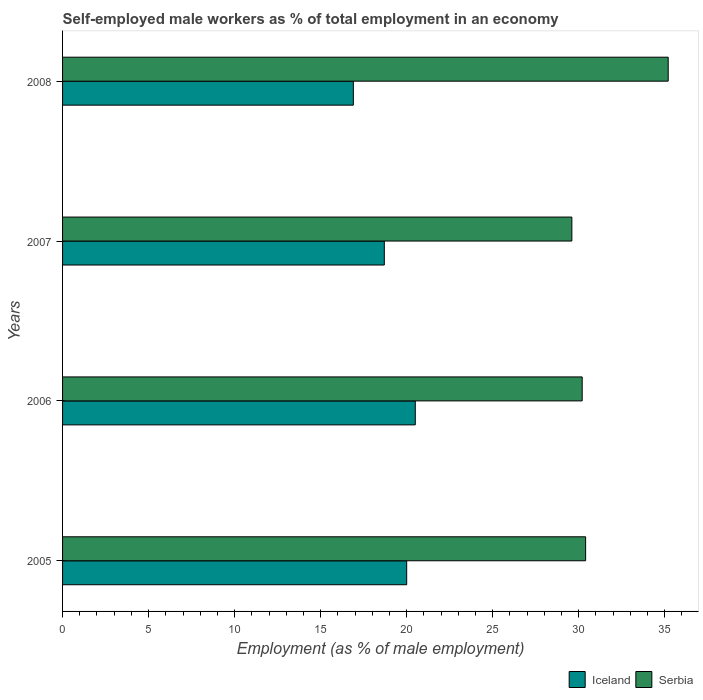How many groups of bars are there?
Keep it short and to the point. 4. Are the number of bars on each tick of the Y-axis equal?
Keep it short and to the point. Yes. How many bars are there on the 2nd tick from the bottom?
Your answer should be very brief. 2. What is the label of the 2nd group of bars from the top?
Your answer should be compact. 2007. In how many cases, is the number of bars for a given year not equal to the number of legend labels?
Your response must be concise. 0. What is the percentage of self-employed male workers in Serbia in 2006?
Your answer should be very brief. 30.2. Across all years, what is the maximum percentage of self-employed male workers in Iceland?
Offer a very short reply. 20.5. Across all years, what is the minimum percentage of self-employed male workers in Iceland?
Keep it short and to the point. 16.9. In which year was the percentage of self-employed male workers in Serbia maximum?
Give a very brief answer. 2008. What is the total percentage of self-employed male workers in Iceland in the graph?
Provide a succinct answer. 76.1. What is the difference between the percentage of self-employed male workers in Iceland in 2005 and that in 2008?
Give a very brief answer. 3.1. What is the difference between the percentage of self-employed male workers in Iceland in 2006 and the percentage of self-employed male workers in Serbia in 2007?
Ensure brevity in your answer.  -9.1. What is the average percentage of self-employed male workers in Iceland per year?
Provide a succinct answer. 19.03. In the year 2005, what is the difference between the percentage of self-employed male workers in Serbia and percentage of self-employed male workers in Iceland?
Your answer should be compact. 10.4. What is the ratio of the percentage of self-employed male workers in Iceland in 2005 to that in 2008?
Provide a short and direct response. 1.18. Is the difference between the percentage of self-employed male workers in Serbia in 2005 and 2008 greater than the difference between the percentage of self-employed male workers in Iceland in 2005 and 2008?
Offer a terse response. No. What is the difference between the highest and the second highest percentage of self-employed male workers in Serbia?
Keep it short and to the point. 4.8. What is the difference between the highest and the lowest percentage of self-employed male workers in Iceland?
Offer a very short reply. 3.6. In how many years, is the percentage of self-employed male workers in Iceland greater than the average percentage of self-employed male workers in Iceland taken over all years?
Give a very brief answer. 2. What does the 2nd bar from the bottom in 2006 represents?
Offer a terse response. Serbia. How many bars are there?
Ensure brevity in your answer.  8. How many years are there in the graph?
Give a very brief answer. 4. What is the difference between two consecutive major ticks on the X-axis?
Provide a short and direct response. 5. Are the values on the major ticks of X-axis written in scientific E-notation?
Provide a short and direct response. No. Does the graph contain grids?
Your response must be concise. No. Where does the legend appear in the graph?
Your response must be concise. Bottom right. How many legend labels are there?
Give a very brief answer. 2. What is the title of the graph?
Your answer should be very brief. Self-employed male workers as % of total employment in an economy. What is the label or title of the X-axis?
Make the answer very short. Employment (as % of male employment). What is the Employment (as % of male employment) of Serbia in 2005?
Your answer should be very brief. 30.4. What is the Employment (as % of male employment) in Iceland in 2006?
Your response must be concise. 20.5. What is the Employment (as % of male employment) of Serbia in 2006?
Keep it short and to the point. 30.2. What is the Employment (as % of male employment) of Iceland in 2007?
Ensure brevity in your answer.  18.7. What is the Employment (as % of male employment) of Serbia in 2007?
Make the answer very short. 29.6. What is the Employment (as % of male employment) in Iceland in 2008?
Offer a very short reply. 16.9. What is the Employment (as % of male employment) of Serbia in 2008?
Offer a terse response. 35.2. Across all years, what is the maximum Employment (as % of male employment) of Iceland?
Ensure brevity in your answer.  20.5. Across all years, what is the maximum Employment (as % of male employment) in Serbia?
Keep it short and to the point. 35.2. Across all years, what is the minimum Employment (as % of male employment) of Iceland?
Ensure brevity in your answer.  16.9. Across all years, what is the minimum Employment (as % of male employment) of Serbia?
Ensure brevity in your answer.  29.6. What is the total Employment (as % of male employment) in Iceland in the graph?
Give a very brief answer. 76.1. What is the total Employment (as % of male employment) in Serbia in the graph?
Give a very brief answer. 125.4. What is the difference between the Employment (as % of male employment) of Iceland in 2005 and that in 2006?
Provide a succinct answer. -0.5. What is the difference between the Employment (as % of male employment) in Serbia in 2005 and that in 2007?
Provide a succinct answer. 0.8. What is the difference between the Employment (as % of male employment) in Iceland in 2005 and that in 2008?
Give a very brief answer. 3.1. What is the difference between the Employment (as % of male employment) in Iceland in 2007 and that in 2008?
Your answer should be very brief. 1.8. What is the difference between the Employment (as % of male employment) in Iceland in 2005 and the Employment (as % of male employment) in Serbia in 2008?
Offer a very short reply. -15.2. What is the difference between the Employment (as % of male employment) of Iceland in 2006 and the Employment (as % of male employment) of Serbia in 2008?
Provide a succinct answer. -14.7. What is the difference between the Employment (as % of male employment) in Iceland in 2007 and the Employment (as % of male employment) in Serbia in 2008?
Ensure brevity in your answer.  -16.5. What is the average Employment (as % of male employment) of Iceland per year?
Your answer should be very brief. 19.02. What is the average Employment (as % of male employment) in Serbia per year?
Offer a very short reply. 31.35. In the year 2005, what is the difference between the Employment (as % of male employment) of Iceland and Employment (as % of male employment) of Serbia?
Your response must be concise. -10.4. In the year 2006, what is the difference between the Employment (as % of male employment) in Iceland and Employment (as % of male employment) in Serbia?
Ensure brevity in your answer.  -9.7. In the year 2007, what is the difference between the Employment (as % of male employment) of Iceland and Employment (as % of male employment) of Serbia?
Your answer should be compact. -10.9. In the year 2008, what is the difference between the Employment (as % of male employment) in Iceland and Employment (as % of male employment) in Serbia?
Your response must be concise. -18.3. What is the ratio of the Employment (as % of male employment) in Iceland in 2005 to that in 2006?
Keep it short and to the point. 0.98. What is the ratio of the Employment (as % of male employment) of Serbia in 2005 to that in 2006?
Give a very brief answer. 1.01. What is the ratio of the Employment (as % of male employment) in Iceland in 2005 to that in 2007?
Provide a short and direct response. 1.07. What is the ratio of the Employment (as % of male employment) in Serbia in 2005 to that in 2007?
Make the answer very short. 1.03. What is the ratio of the Employment (as % of male employment) in Iceland in 2005 to that in 2008?
Offer a very short reply. 1.18. What is the ratio of the Employment (as % of male employment) in Serbia in 2005 to that in 2008?
Provide a short and direct response. 0.86. What is the ratio of the Employment (as % of male employment) of Iceland in 2006 to that in 2007?
Keep it short and to the point. 1.1. What is the ratio of the Employment (as % of male employment) in Serbia in 2006 to that in 2007?
Offer a terse response. 1.02. What is the ratio of the Employment (as % of male employment) of Iceland in 2006 to that in 2008?
Offer a very short reply. 1.21. What is the ratio of the Employment (as % of male employment) of Serbia in 2006 to that in 2008?
Offer a terse response. 0.86. What is the ratio of the Employment (as % of male employment) of Iceland in 2007 to that in 2008?
Give a very brief answer. 1.11. What is the ratio of the Employment (as % of male employment) in Serbia in 2007 to that in 2008?
Your answer should be compact. 0.84. What is the difference between the highest and the second highest Employment (as % of male employment) in Iceland?
Provide a short and direct response. 0.5. What is the difference between the highest and the lowest Employment (as % of male employment) in Iceland?
Your answer should be compact. 3.6. 